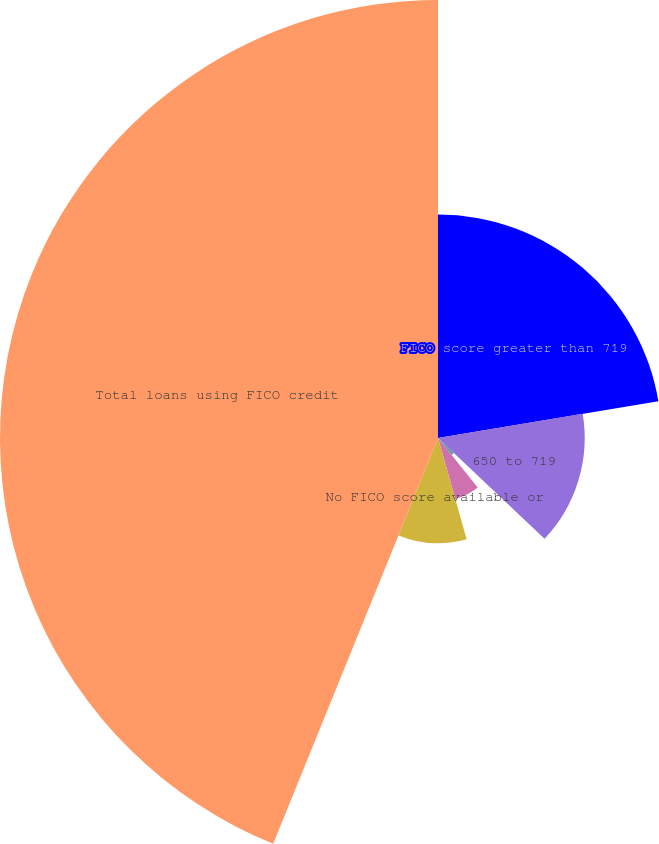Convert chart. <chart><loc_0><loc_0><loc_500><loc_500><pie_chart><fcel>FICO score greater than 719<fcel>650 to 719<fcel>620 to 649<fcel>Less than 620<fcel>No FICO score available or<fcel>Total loans using FICO credit<nl><fcel>22.37%<fcel>14.69%<fcel>2.19%<fcel>6.36%<fcel>10.53%<fcel>43.86%<nl></chart> 